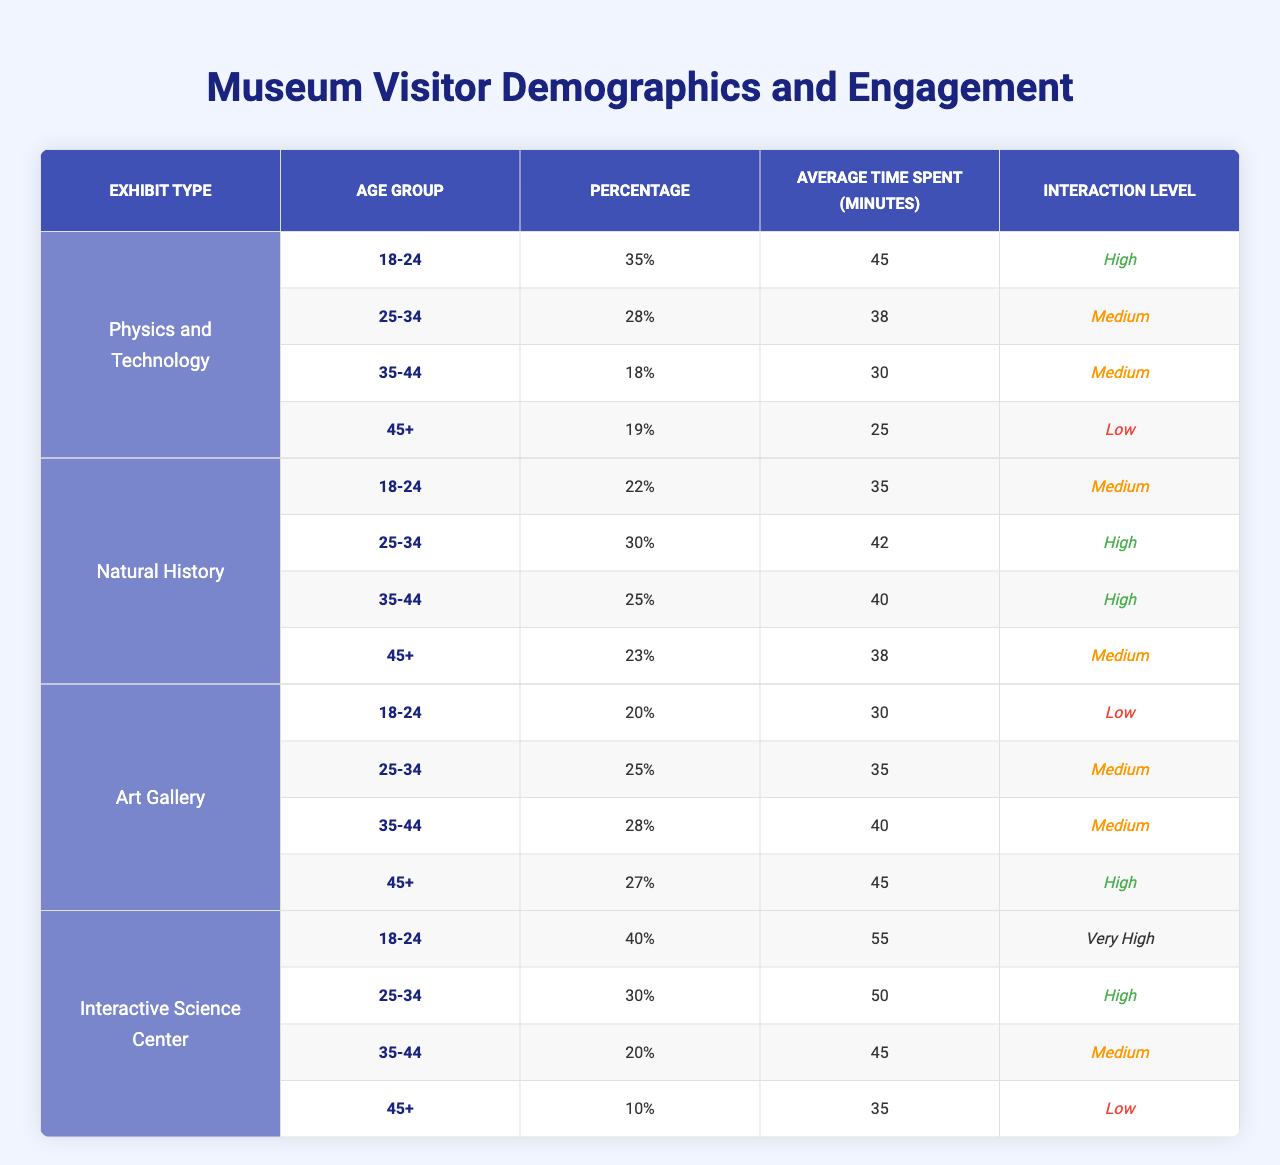What age group has the highest percentage of visitors in the Physics and Technology exhibit? In the Physics and Technology exhibit, the 18-24 age group has the highest percentage of visitors at 35%.
Answer: 18-24 What is the average time spent by visitors aged 25-34 in the Art Gallery? In the Art Gallery, visitors aged 25-34 spend an average of 35 minutes.
Answer: 35 Which exhibit type has the highest interaction level for visitors aged 45+? In the table, the Art Gallery has a high interaction level for visitors aged 45+, compared to other exhibits which are low or medium.
Answer: Art Gallery Calculate the total percentage of visitors aged 18-24 across all exhibit types. Adding the percentages: Physics and Technology (35) + Natural History (22) + Art Gallery (20) + Interactive Science Center (40) = 117%.
Answer: 117% Is there a significant difference in average time spent by the 35-44 age group between the Physics and Technology exhibit and the Natural History exhibit? The 35-44 age group spends 30 minutes in the Physics and Technology exhibit and 40 minutes in Natural History, indicating a difference of 10 minutes.
Answer: Yes Which age group has the lowest engagement level in the Interactive Science Center? In the Interactive Science Center, visitors aged 45+ have a low engagement level.
Answer: 45+ What is the average percentage of visitors across all age groups for the Natural History exhibit? The percentages are 22%, 30%, 25%, and 23%. The average is (22 + 30 + 25 + 23) / 4 = 25%.
Answer: 25 Which exhibit type has the highest average time spent by visitors aged 18-24? The Interactive Science Center has the highest average time spent at 55 minutes for visitors aged 18-24.
Answer: Interactive Science Center If the percentages of visitors aged 45+ are summed across all exhibit types, what is the total? The totals for the 45+ age group are: Physics and Technology (19) + Natural History (23) + Art Gallery (27) + Interactive Science Center (10) = 79%.
Answer: 79 Is it true that visitors aged 25-34 spend more time in the Natural History exhibit than in the Art Gallery? Visitors aged 25-34 spend 42 minutes in Natural History and 35 minutes in the Art Gallery, confirming that they spend more time in Natural History.
Answer: Yes 